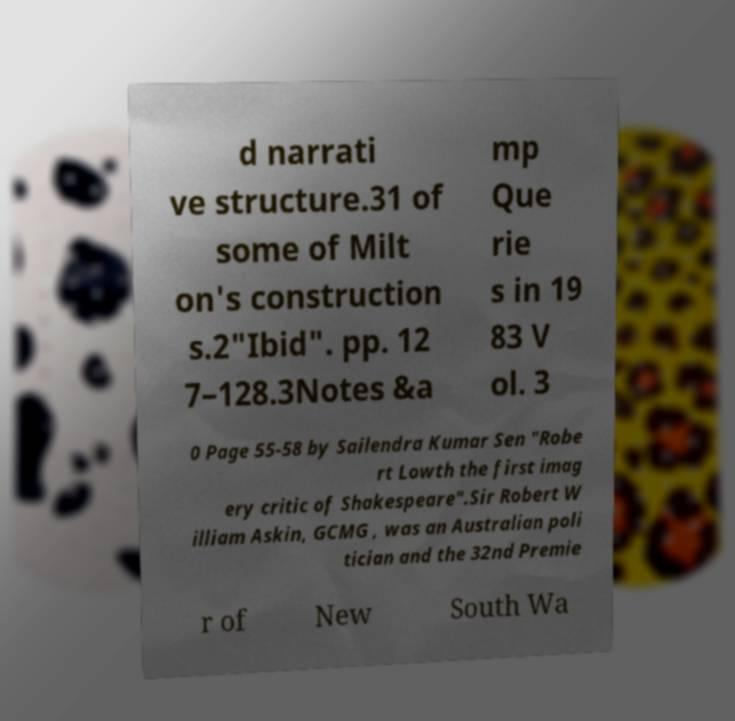For documentation purposes, I need the text within this image transcribed. Could you provide that? d narrati ve structure.31 of some of Milt on's construction s.2"Ibid". pp. 12 7–128.3Notes &a mp Que rie s in 19 83 V ol. 3 0 Page 55-58 by Sailendra Kumar Sen "Robe rt Lowth the first imag ery critic of Shakespeare".Sir Robert W illiam Askin, GCMG , was an Australian poli tician and the 32nd Premie r of New South Wa 